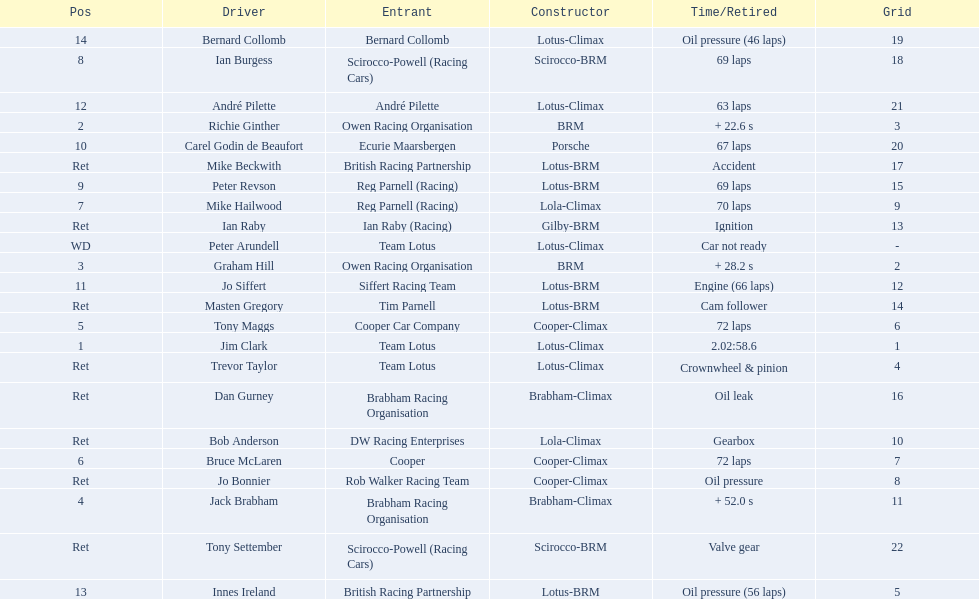Who were the two that that a similar problem? Innes Ireland. What was their common problem? Oil pressure. Write the full table. {'header': ['Pos', 'Driver', 'Entrant', 'Constructor', 'Time/Retired', 'Grid'], 'rows': [['14', 'Bernard Collomb', 'Bernard Collomb', 'Lotus-Climax', 'Oil pressure (46 laps)', '19'], ['8', 'Ian Burgess', 'Scirocco-Powell (Racing Cars)', 'Scirocco-BRM', '69 laps', '18'], ['12', 'André Pilette', 'André Pilette', 'Lotus-Climax', '63 laps', '21'], ['2', 'Richie Ginther', 'Owen Racing Organisation', 'BRM', '+ 22.6 s', '3'], ['10', 'Carel Godin de Beaufort', 'Ecurie Maarsbergen', 'Porsche', '67 laps', '20'], ['Ret', 'Mike Beckwith', 'British Racing Partnership', 'Lotus-BRM', 'Accident', '17'], ['9', 'Peter Revson', 'Reg Parnell (Racing)', 'Lotus-BRM', '69 laps', '15'], ['7', 'Mike Hailwood', 'Reg Parnell (Racing)', 'Lola-Climax', '70 laps', '9'], ['Ret', 'Ian Raby', 'Ian Raby (Racing)', 'Gilby-BRM', 'Ignition', '13'], ['WD', 'Peter Arundell', 'Team Lotus', 'Lotus-Climax', 'Car not ready', '-'], ['3', 'Graham Hill', 'Owen Racing Organisation', 'BRM', '+ 28.2 s', '2'], ['11', 'Jo Siffert', 'Siffert Racing Team', 'Lotus-BRM', 'Engine (66 laps)', '12'], ['Ret', 'Masten Gregory', 'Tim Parnell', 'Lotus-BRM', 'Cam follower', '14'], ['5', 'Tony Maggs', 'Cooper Car Company', 'Cooper-Climax', '72 laps', '6'], ['1', 'Jim Clark', 'Team Lotus', 'Lotus-Climax', '2.02:58.6', '1'], ['Ret', 'Trevor Taylor', 'Team Lotus', 'Lotus-Climax', 'Crownwheel & pinion', '4'], ['Ret', 'Dan Gurney', 'Brabham Racing Organisation', 'Brabham-Climax', 'Oil leak', '16'], ['Ret', 'Bob Anderson', 'DW Racing Enterprises', 'Lola-Climax', 'Gearbox', '10'], ['6', 'Bruce McLaren', 'Cooper', 'Cooper-Climax', '72 laps', '7'], ['Ret', 'Jo Bonnier', 'Rob Walker Racing Team', 'Cooper-Climax', 'Oil pressure', '8'], ['4', 'Jack Brabham', 'Brabham Racing Organisation', 'Brabham-Climax', '+ 52.0 s', '11'], ['Ret', 'Tony Settember', 'Scirocco-Powell (Racing Cars)', 'Scirocco-BRM', 'Valve gear', '22'], ['13', 'Innes Ireland', 'British Racing Partnership', 'Lotus-BRM', 'Oil pressure (56 laps)', '5']]} 